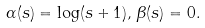<formula> <loc_0><loc_0><loc_500><loc_500>\alpha ( s ) = \log ( s + 1 ) , \, \beta ( s ) = 0 .</formula> 